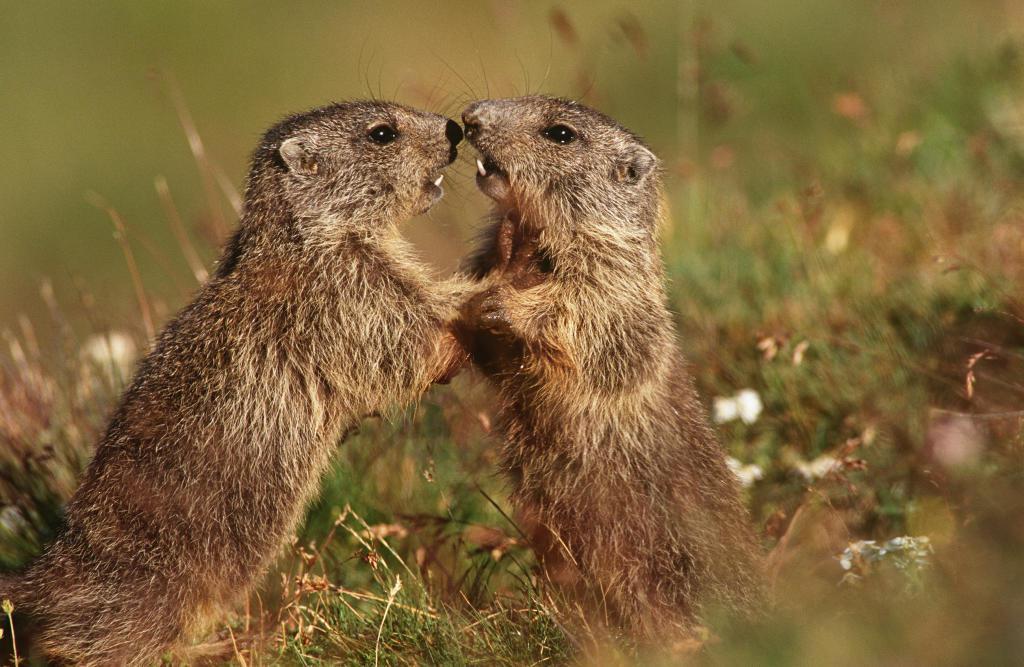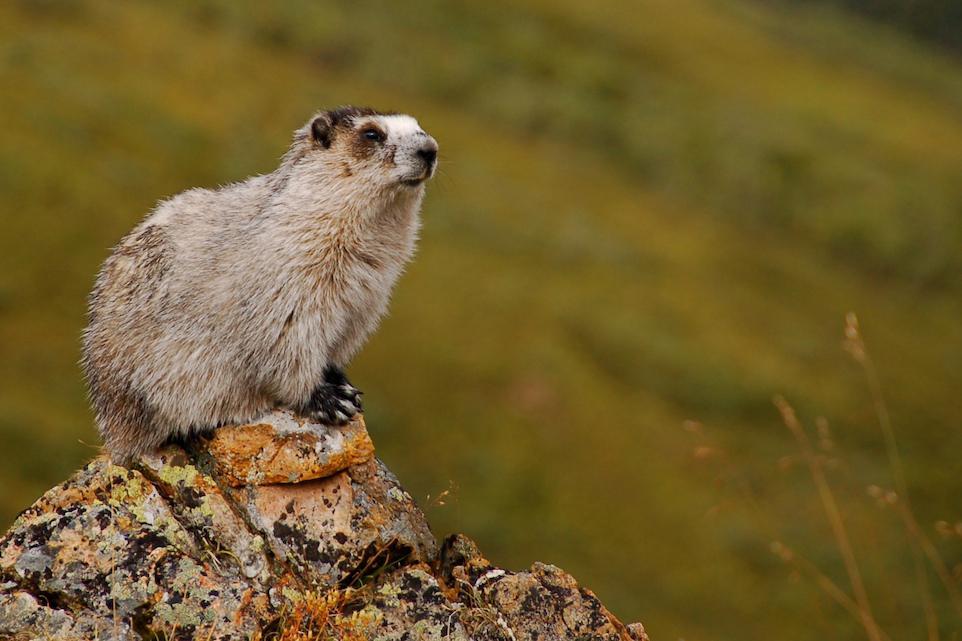The first image is the image on the left, the second image is the image on the right. Evaluate the accuracy of this statement regarding the images: "There are more than two animals total.". Is it true? Answer yes or no. Yes. 